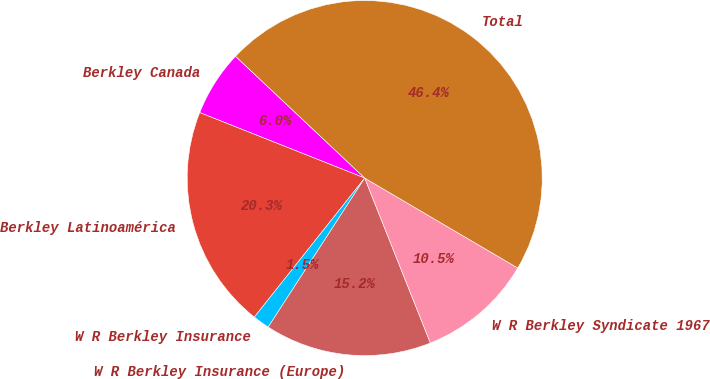Convert chart. <chart><loc_0><loc_0><loc_500><loc_500><pie_chart><fcel>Berkley Canada<fcel>Berkley Latinoamérica<fcel>W R Berkley Insurance<fcel>W R Berkley Insurance (Europe)<fcel>W R Berkley Syndicate 1967<fcel>Total<nl><fcel>6.02%<fcel>20.33%<fcel>1.53%<fcel>15.18%<fcel>10.51%<fcel>46.42%<nl></chart> 